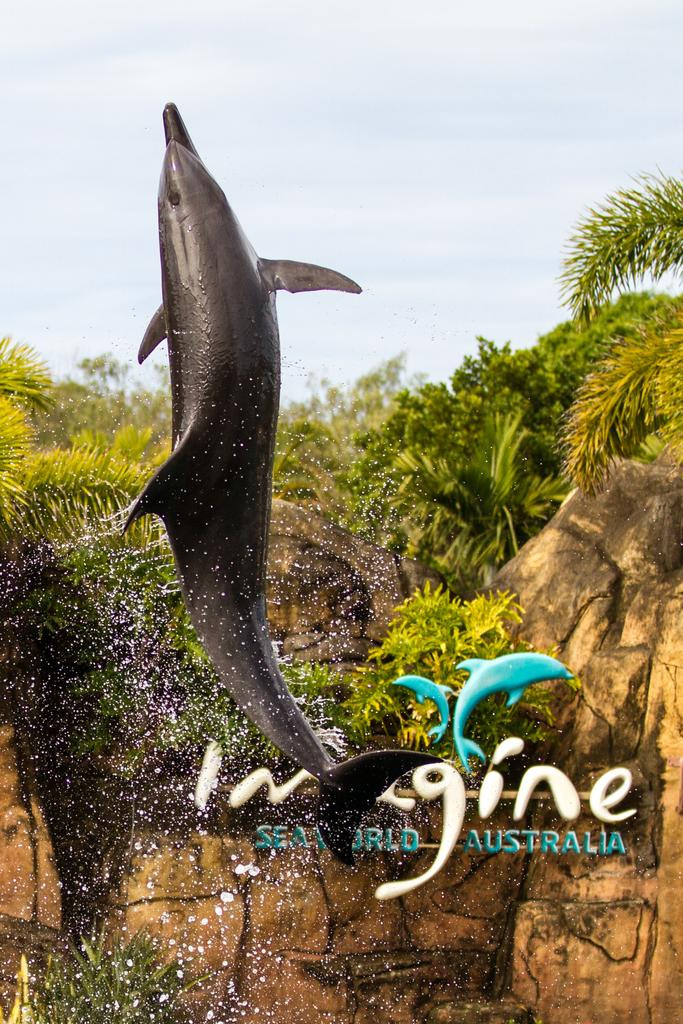What animal is featured in the image? There is a dolphin in the image. What is the dolphin doing in the image? The dolphin is in the air. What can be seen in the image besides the dolphin? Water droplets, a board, rocks, trees, and the sky are visible in the background of the image. What is the rate of the dolphin's request in the image? There is no indication of a request or rate in the image; it simply shows a dolphin in the air. 